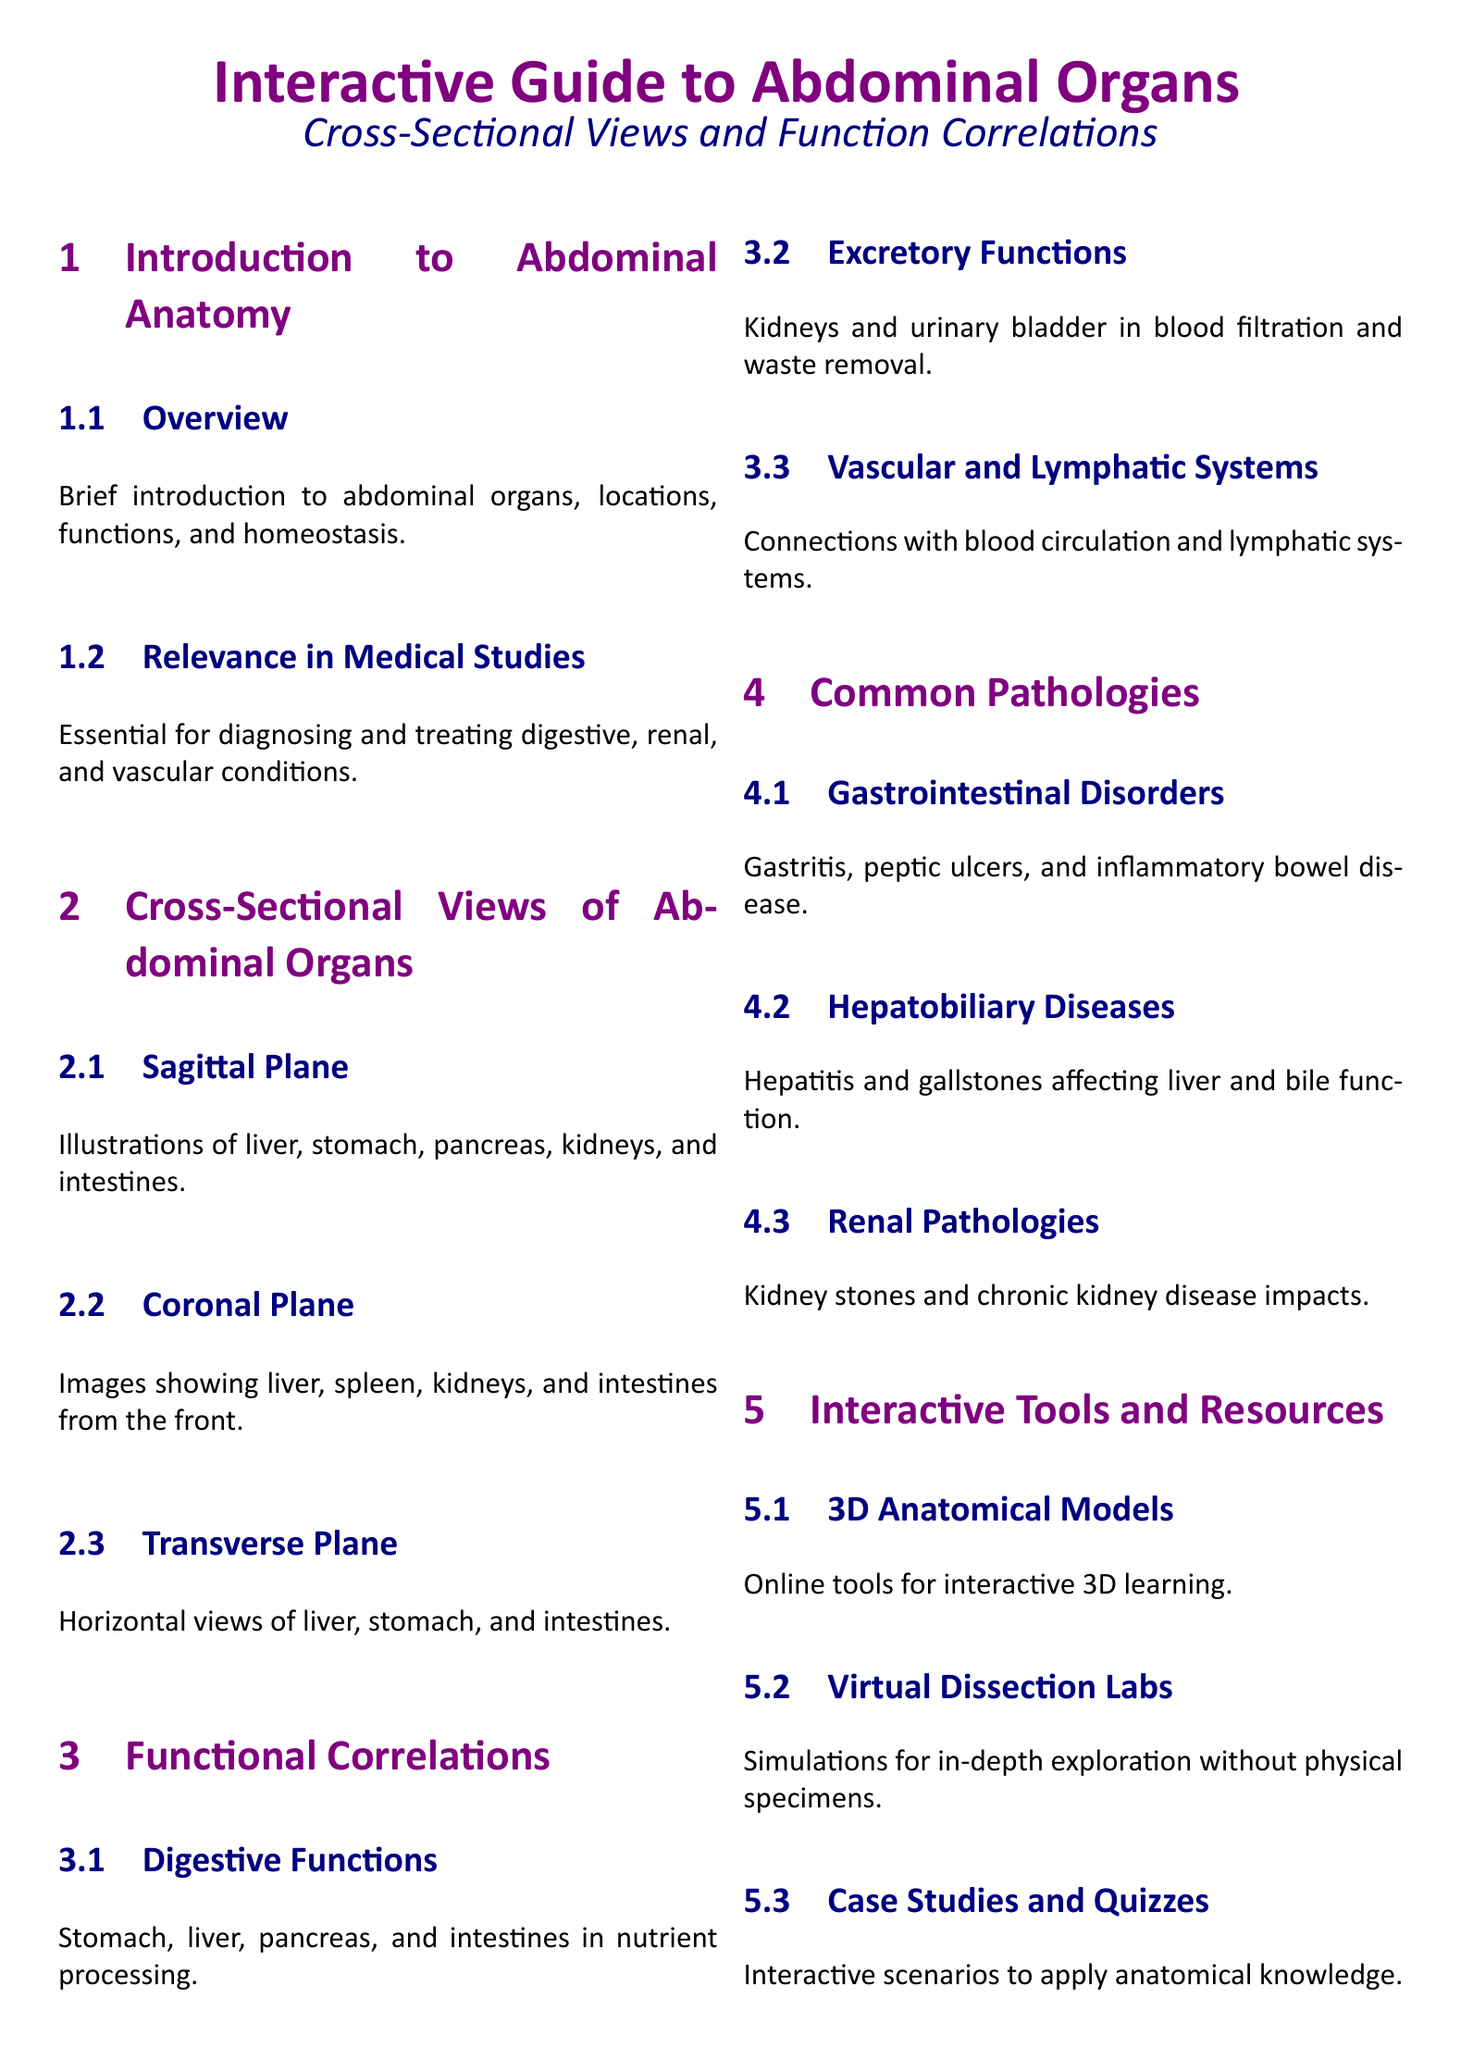What is the main topic of the document? The main topic is an interactive guide focused on abdominal organs, emphasizing cross-sectional views and their functional correlations.
Answer: Interactive Guide to Abdominal Organs What anatomical planes are discussed? The document outlines three anatomical planes used to view abdominal organs: sagittal, coronal, and transverse.
Answer: Sagittal, Coronal, Transverse Which organs are illustrated in the sagittal plane? The sagittal plane section specifically illustrates the liver, stomach, pancreas, kidneys, and intestines.
Answer: Liver, stomach, pancreas, kidneys, intestines What are the common gastrointestinal disorders mentioned? The document lists gastritis, peptic ulcers, and inflammatory bowel disease as common gastrointestinal disorders.
Answer: Gastritis, peptic ulcers, inflammatory bowel disease What is the significance of abdominal anatomy in medical studies? Understanding abdominal anatomy is crucial for diagnosing and treating various digestive, renal, and vascular conditions.
Answer: Essential for diagnosing and treating conditions Which interactive resources are available for learning? The document mentions 3D anatomical models, virtual dissection labs, and case studies/quizzes as interactive resources for learning.
Answer: 3D anatomical models, virtual dissection labs, case studies, quizzes What type of pathologies affect the liver discussed in the document? The document addresses hepatobiliary diseases, specifically hepatitis and gallstones that impact liver function.
Answer: Hepatitis, gallstones How are kidneys involved in the body’s functions? The kidneys' role in the body is primarily blood filtration and waste removal as described in the document.
Answer: Blood filtration and waste removal 